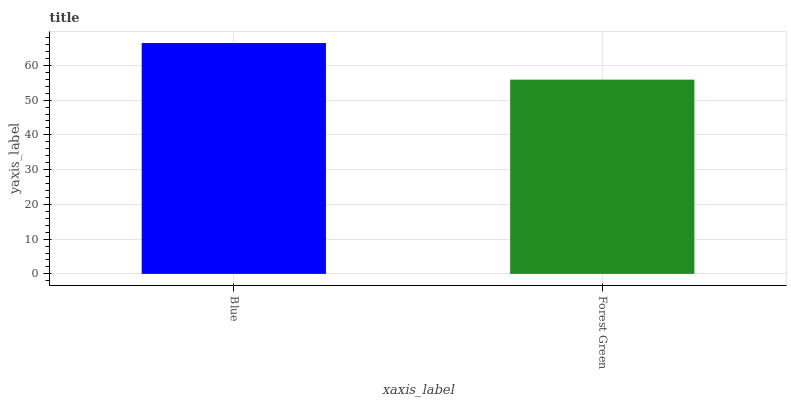Is Forest Green the minimum?
Answer yes or no. Yes. Is Blue the maximum?
Answer yes or no. Yes. Is Forest Green the maximum?
Answer yes or no. No. Is Blue greater than Forest Green?
Answer yes or no. Yes. Is Forest Green less than Blue?
Answer yes or no. Yes. Is Forest Green greater than Blue?
Answer yes or no. No. Is Blue less than Forest Green?
Answer yes or no. No. Is Blue the high median?
Answer yes or no. Yes. Is Forest Green the low median?
Answer yes or no. Yes. Is Forest Green the high median?
Answer yes or no. No. Is Blue the low median?
Answer yes or no. No. 